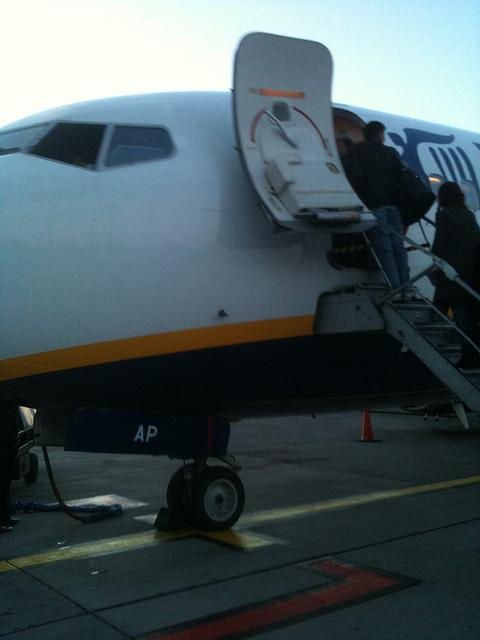What popular news agency as the same Acronym as the letters near the bottom of the plane?

Choices:
A) associated press
B) amazing press
C) awesome people
D) associated people associated press 